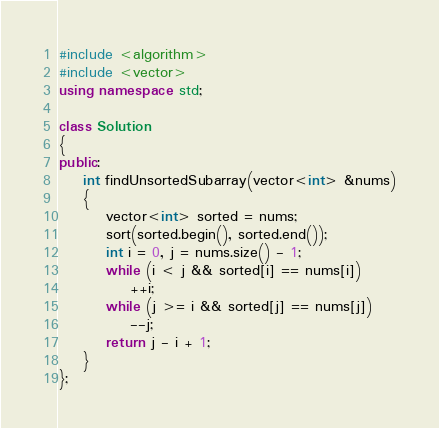<code> <loc_0><loc_0><loc_500><loc_500><_C++_>#include <algorithm>
#include <vector>
using namespace std;

class Solution
{
public:
	int findUnsortedSubarray(vector<int> &nums)
	{
		vector<int> sorted = nums;
		sort(sorted.begin(), sorted.end());
		int i = 0, j = nums.size() - 1;
		while (i < j && sorted[i] == nums[i])
			++i;
		while (j >= i && sorted[j] == nums[j])
			--j;
		return j - i + 1;
	}
};</code> 